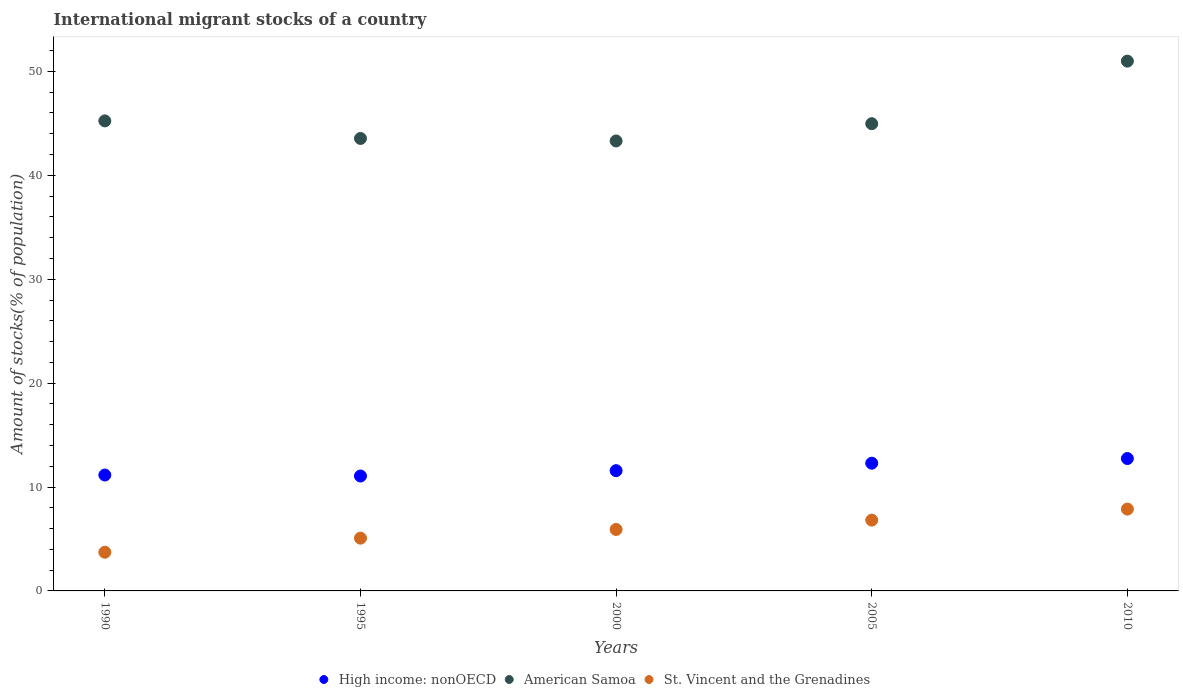Is the number of dotlines equal to the number of legend labels?
Ensure brevity in your answer.  Yes. What is the amount of stocks in in St. Vincent and the Grenadines in 1990?
Give a very brief answer. 3.72. Across all years, what is the maximum amount of stocks in in St. Vincent and the Grenadines?
Make the answer very short. 7.88. Across all years, what is the minimum amount of stocks in in American Samoa?
Provide a succinct answer. 43.31. In which year was the amount of stocks in in American Samoa minimum?
Make the answer very short. 2000. What is the total amount of stocks in in American Samoa in the graph?
Your answer should be compact. 228.06. What is the difference between the amount of stocks in in High income: nonOECD in 1995 and that in 2010?
Provide a succinct answer. -1.68. What is the difference between the amount of stocks in in American Samoa in 1995 and the amount of stocks in in St. Vincent and the Grenadines in 2010?
Offer a very short reply. 35.67. What is the average amount of stocks in in St. Vincent and the Grenadines per year?
Keep it short and to the point. 5.88. In the year 2010, what is the difference between the amount of stocks in in American Samoa and amount of stocks in in St. Vincent and the Grenadines?
Offer a very short reply. 43.11. What is the ratio of the amount of stocks in in St. Vincent and the Grenadines in 1990 to that in 2000?
Give a very brief answer. 0.63. Is the amount of stocks in in American Samoa in 1990 less than that in 2000?
Your answer should be compact. No. What is the difference between the highest and the second highest amount of stocks in in St. Vincent and the Grenadines?
Make the answer very short. 1.06. What is the difference between the highest and the lowest amount of stocks in in American Samoa?
Provide a short and direct response. 7.68. Is the sum of the amount of stocks in in American Samoa in 2005 and 2010 greater than the maximum amount of stocks in in High income: nonOECD across all years?
Your answer should be compact. Yes. Is it the case that in every year, the sum of the amount of stocks in in High income: nonOECD and amount of stocks in in St. Vincent and the Grenadines  is greater than the amount of stocks in in American Samoa?
Keep it short and to the point. No. Is the amount of stocks in in American Samoa strictly less than the amount of stocks in in High income: nonOECD over the years?
Keep it short and to the point. No. How many dotlines are there?
Keep it short and to the point. 3. How many years are there in the graph?
Give a very brief answer. 5. What is the difference between two consecutive major ticks on the Y-axis?
Offer a very short reply. 10. Are the values on the major ticks of Y-axis written in scientific E-notation?
Your response must be concise. No. Does the graph contain grids?
Your answer should be very brief. No. How are the legend labels stacked?
Provide a short and direct response. Horizontal. What is the title of the graph?
Your answer should be compact. International migrant stocks of a country. Does "Moldova" appear as one of the legend labels in the graph?
Ensure brevity in your answer.  No. What is the label or title of the X-axis?
Keep it short and to the point. Years. What is the label or title of the Y-axis?
Provide a short and direct response. Amount of stocks(% of population). What is the Amount of stocks(% of population) of High income: nonOECD in 1990?
Make the answer very short. 11.16. What is the Amount of stocks(% of population) in American Samoa in 1990?
Your response must be concise. 45.24. What is the Amount of stocks(% of population) in St. Vincent and the Grenadines in 1990?
Your response must be concise. 3.72. What is the Amount of stocks(% of population) of High income: nonOECD in 1995?
Provide a short and direct response. 11.06. What is the Amount of stocks(% of population) of American Samoa in 1995?
Offer a terse response. 43.55. What is the Amount of stocks(% of population) of St. Vincent and the Grenadines in 1995?
Give a very brief answer. 5.08. What is the Amount of stocks(% of population) of High income: nonOECD in 2000?
Make the answer very short. 11.58. What is the Amount of stocks(% of population) of American Samoa in 2000?
Provide a short and direct response. 43.31. What is the Amount of stocks(% of population) of St. Vincent and the Grenadines in 2000?
Give a very brief answer. 5.91. What is the Amount of stocks(% of population) in High income: nonOECD in 2005?
Offer a very short reply. 12.29. What is the Amount of stocks(% of population) of American Samoa in 2005?
Your answer should be compact. 44.97. What is the Amount of stocks(% of population) in St. Vincent and the Grenadines in 2005?
Your answer should be very brief. 6.82. What is the Amount of stocks(% of population) in High income: nonOECD in 2010?
Make the answer very short. 12.74. What is the Amount of stocks(% of population) in American Samoa in 2010?
Ensure brevity in your answer.  50.99. What is the Amount of stocks(% of population) in St. Vincent and the Grenadines in 2010?
Keep it short and to the point. 7.88. Across all years, what is the maximum Amount of stocks(% of population) of High income: nonOECD?
Provide a short and direct response. 12.74. Across all years, what is the maximum Amount of stocks(% of population) of American Samoa?
Your answer should be compact. 50.99. Across all years, what is the maximum Amount of stocks(% of population) of St. Vincent and the Grenadines?
Give a very brief answer. 7.88. Across all years, what is the minimum Amount of stocks(% of population) of High income: nonOECD?
Offer a terse response. 11.06. Across all years, what is the minimum Amount of stocks(% of population) in American Samoa?
Ensure brevity in your answer.  43.31. Across all years, what is the minimum Amount of stocks(% of population) in St. Vincent and the Grenadines?
Your answer should be compact. 3.72. What is the total Amount of stocks(% of population) in High income: nonOECD in the graph?
Make the answer very short. 58.83. What is the total Amount of stocks(% of population) of American Samoa in the graph?
Keep it short and to the point. 228.06. What is the total Amount of stocks(% of population) in St. Vincent and the Grenadines in the graph?
Give a very brief answer. 29.41. What is the difference between the Amount of stocks(% of population) in High income: nonOECD in 1990 and that in 1995?
Ensure brevity in your answer.  0.1. What is the difference between the Amount of stocks(% of population) of American Samoa in 1990 and that in 1995?
Offer a very short reply. 1.69. What is the difference between the Amount of stocks(% of population) in St. Vincent and the Grenadines in 1990 and that in 1995?
Keep it short and to the point. -1.36. What is the difference between the Amount of stocks(% of population) in High income: nonOECD in 1990 and that in 2000?
Your answer should be compact. -0.42. What is the difference between the Amount of stocks(% of population) of American Samoa in 1990 and that in 2000?
Ensure brevity in your answer.  1.93. What is the difference between the Amount of stocks(% of population) in St. Vincent and the Grenadines in 1990 and that in 2000?
Give a very brief answer. -2.19. What is the difference between the Amount of stocks(% of population) in High income: nonOECD in 1990 and that in 2005?
Provide a short and direct response. -1.14. What is the difference between the Amount of stocks(% of population) of American Samoa in 1990 and that in 2005?
Provide a succinct answer. 0.27. What is the difference between the Amount of stocks(% of population) of St. Vincent and the Grenadines in 1990 and that in 2005?
Keep it short and to the point. -3.09. What is the difference between the Amount of stocks(% of population) of High income: nonOECD in 1990 and that in 2010?
Your answer should be very brief. -1.59. What is the difference between the Amount of stocks(% of population) in American Samoa in 1990 and that in 2010?
Provide a succinct answer. -5.75. What is the difference between the Amount of stocks(% of population) in St. Vincent and the Grenadines in 1990 and that in 2010?
Your answer should be very brief. -4.15. What is the difference between the Amount of stocks(% of population) of High income: nonOECD in 1995 and that in 2000?
Ensure brevity in your answer.  -0.52. What is the difference between the Amount of stocks(% of population) of American Samoa in 1995 and that in 2000?
Your answer should be compact. 0.24. What is the difference between the Amount of stocks(% of population) in St. Vincent and the Grenadines in 1995 and that in 2000?
Keep it short and to the point. -0.83. What is the difference between the Amount of stocks(% of population) in High income: nonOECD in 1995 and that in 2005?
Provide a short and direct response. -1.23. What is the difference between the Amount of stocks(% of population) in American Samoa in 1995 and that in 2005?
Provide a succinct answer. -1.42. What is the difference between the Amount of stocks(% of population) of St. Vincent and the Grenadines in 1995 and that in 2005?
Your response must be concise. -1.74. What is the difference between the Amount of stocks(% of population) in High income: nonOECD in 1995 and that in 2010?
Provide a succinct answer. -1.68. What is the difference between the Amount of stocks(% of population) in American Samoa in 1995 and that in 2010?
Make the answer very short. -7.44. What is the difference between the Amount of stocks(% of population) in St. Vincent and the Grenadines in 1995 and that in 2010?
Ensure brevity in your answer.  -2.8. What is the difference between the Amount of stocks(% of population) of High income: nonOECD in 2000 and that in 2005?
Your response must be concise. -0.72. What is the difference between the Amount of stocks(% of population) of American Samoa in 2000 and that in 2005?
Offer a terse response. -1.66. What is the difference between the Amount of stocks(% of population) of St. Vincent and the Grenadines in 2000 and that in 2005?
Your response must be concise. -0.9. What is the difference between the Amount of stocks(% of population) of High income: nonOECD in 2000 and that in 2010?
Give a very brief answer. -1.17. What is the difference between the Amount of stocks(% of population) of American Samoa in 2000 and that in 2010?
Your answer should be very brief. -7.68. What is the difference between the Amount of stocks(% of population) in St. Vincent and the Grenadines in 2000 and that in 2010?
Keep it short and to the point. -1.96. What is the difference between the Amount of stocks(% of population) of High income: nonOECD in 2005 and that in 2010?
Your response must be concise. -0.45. What is the difference between the Amount of stocks(% of population) of American Samoa in 2005 and that in 2010?
Offer a very short reply. -6.02. What is the difference between the Amount of stocks(% of population) of St. Vincent and the Grenadines in 2005 and that in 2010?
Give a very brief answer. -1.06. What is the difference between the Amount of stocks(% of population) of High income: nonOECD in 1990 and the Amount of stocks(% of population) of American Samoa in 1995?
Offer a terse response. -32.39. What is the difference between the Amount of stocks(% of population) in High income: nonOECD in 1990 and the Amount of stocks(% of population) in St. Vincent and the Grenadines in 1995?
Provide a succinct answer. 6.08. What is the difference between the Amount of stocks(% of population) in American Samoa in 1990 and the Amount of stocks(% of population) in St. Vincent and the Grenadines in 1995?
Give a very brief answer. 40.16. What is the difference between the Amount of stocks(% of population) of High income: nonOECD in 1990 and the Amount of stocks(% of population) of American Samoa in 2000?
Offer a very short reply. -32.15. What is the difference between the Amount of stocks(% of population) of High income: nonOECD in 1990 and the Amount of stocks(% of population) of St. Vincent and the Grenadines in 2000?
Offer a terse response. 5.24. What is the difference between the Amount of stocks(% of population) of American Samoa in 1990 and the Amount of stocks(% of population) of St. Vincent and the Grenadines in 2000?
Your response must be concise. 39.33. What is the difference between the Amount of stocks(% of population) of High income: nonOECD in 1990 and the Amount of stocks(% of population) of American Samoa in 2005?
Offer a very short reply. -33.81. What is the difference between the Amount of stocks(% of population) in High income: nonOECD in 1990 and the Amount of stocks(% of population) in St. Vincent and the Grenadines in 2005?
Give a very brief answer. 4.34. What is the difference between the Amount of stocks(% of population) of American Samoa in 1990 and the Amount of stocks(% of population) of St. Vincent and the Grenadines in 2005?
Your answer should be compact. 38.42. What is the difference between the Amount of stocks(% of population) of High income: nonOECD in 1990 and the Amount of stocks(% of population) of American Samoa in 2010?
Keep it short and to the point. -39.84. What is the difference between the Amount of stocks(% of population) of High income: nonOECD in 1990 and the Amount of stocks(% of population) of St. Vincent and the Grenadines in 2010?
Offer a very short reply. 3.28. What is the difference between the Amount of stocks(% of population) of American Samoa in 1990 and the Amount of stocks(% of population) of St. Vincent and the Grenadines in 2010?
Offer a terse response. 37.36. What is the difference between the Amount of stocks(% of population) of High income: nonOECD in 1995 and the Amount of stocks(% of population) of American Samoa in 2000?
Your answer should be very brief. -32.25. What is the difference between the Amount of stocks(% of population) of High income: nonOECD in 1995 and the Amount of stocks(% of population) of St. Vincent and the Grenadines in 2000?
Offer a terse response. 5.15. What is the difference between the Amount of stocks(% of population) of American Samoa in 1995 and the Amount of stocks(% of population) of St. Vincent and the Grenadines in 2000?
Provide a succinct answer. 37.64. What is the difference between the Amount of stocks(% of population) of High income: nonOECD in 1995 and the Amount of stocks(% of population) of American Samoa in 2005?
Offer a very short reply. -33.91. What is the difference between the Amount of stocks(% of population) in High income: nonOECD in 1995 and the Amount of stocks(% of population) in St. Vincent and the Grenadines in 2005?
Offer a very short reply. 4.24. What is the difference between the Amount of stocks(% of population) of American Samoa in 1995 and the Amount of stocks(% of population) of St. Vincent and the Grenadines in 2005?
Ensure brevity in your answer.  36.73. What is the difference between the Amount of stocks(% of population) of High income: nonOECD in 1995 and the Amount of stocks(% of population) of American Samoa in 2010?
Your response must be concise. -39.93. What is the difference between the Amount of stocks(% of population) of High income: nonOECD in 1995 and the Amount of stocks(% of population) of St. Vincent and the Grenadines in 2010?
Make the answer very short. 3.18. What is the difference between the Amount of stocks(% of population) of American Samoa in 1995 and the Amount of stocks(% of population) of St. Vincent and the Grenadines in 2010?
Your answer should be compact. 35.67. What is the difference between the Amount of stocks(% of population) in High income: nonOECD in 2000 and the Amount of stocks(% of population) in American Samoa in 2005?
Make the answer very short. -33.39. What is the difference between the Amount of stocks(% of population) of High income: nonOECD in 2000 and the Amount of stocks(% of population) of St. Vincent and the Grenadines in 2005?
Offer a very short reply. 4.76. What is the difference between the Amount of stocks(% of population) of American Samoa in 2000 and the Amount of stocks(% of population) of St. Vincent and the Grenadines in 2005?
Provide a succinct answer. 36.49. What is the difference between the Amount of stocks(% of population) in High income: nonOECD in 2000 and the Amount of stocks(% of population) in American Samoa in 2010?
Provide a succinct answer. -39.42. What is the difference between the Amount of stocks(% of population) in High income: nonOECD in 2000 and the Amount of stocks(% of population) in St. Vincent and the Grenadines in 2010?
Ensure brevity in your answer.  3.7. What is the difference between the Amount of stocks(% of population) in American Samoa in 2000 and the Amount of stocks(% of population) in St. Vincent and the Grenadines in 2010?
Ensure brevity in your answer.  35.43. What is the difference between the Amount of stocks(% of population) in High income: nonOECD in 2005 and the Amount of stocks(% of population) in American Samoa in 2010?
Make the answer very short. -38.7. What is the difference between the Amount of stocks(% of population) in High income: nonOECD in 2005 and the Amount of stocks(% of population) in St. Vincent and the Grenadines in 2010?
Provide a short and direct response. 4.42. What is the difference between the Amount of stocks(% of population) of American Samoa in 2005 and the Amount of stocks(% of population) of St. Vincent and the Grenadines in 2010?
Give a very brief answer. 37.09. What is the average Amount of stocks(% of population) of High income: nonOECD per year?
Ensure brevity in your answer.  11.77. What is the average Amount of stocks(% of population) of American Samoa per year?
Provide a succinct answer. 45.61. What is the average Amount of stocks(% of population) of St. Vincent and the Grenadines per year?
Provide a succinct answer. 5.88. In the year 1990, what is the difference between the Amount of stocks(% of population) of High income: nonOECD and Amount of stocks(% of population) of American Samoa?
Ensure brevity in your answer.  -34.08. In the year 1990, what is the difference between the Amount of stocks(% of population) of High income: nonOECD and Amount of stocks(% of population) of St. Vincent and the Grenadines?
Give a very brief answer. 7.43. In the year 1990, what is the difference between the Amount of stocks(% of population) of American Samoa and Amount of stocks(% of population) of St. Vincent and the Grenadines?
Your response must be concise. 41.52. In the year 1995, what is the difference between the Amount of stocks(% of population) of High income: nonOECD and Amount of stocks(% of population) of American Samoa?
Provide a short and direct response. -32.49. In the year 1995, what is the difference between the Amount of stocks(% of population) in High income: nonOECD and Amount of stocks(% of population) in St. Vincent and the Grenadines?
Offer a very short reply. 5.98. In the year 1995, what is the difference between the Amount of stocks(% of population) of American Samoa and Amount of stocks(% of population) of St. Vincent and the Grenadines?
Make the answer very short. 38.47. In the year 2000, what is the difference between the Amount of stocks(% of population) in High income: nonOECD and Amount of stocks(% of population) in American Samoa?
Ensure brevity in your answer.  -31.73. In the year 2000, what is the difference between the Amount of stocks(% of population) in High income: nonOECD and Amount of stocks(% of population) in St. Vincent and the Grenadines?
Ensure brevity in your answer.  5.66. In the year 2000, what is the difference between the Amount of stocks(% of population) of American Samoa and Amount of stocks(% of population) of St. Vincent and the Grenadines?
Make the answer very short. 37.4. In the year 2005, what is the difference between the Amount of stocks(% of population) of High income: nonOECD and Amount of stocks(% of population) of American Samoa?
Provide a short and direct response. -32.68. In the year 2005, what is the difference between the Amount of stocks(% of population) of High income: nonOECD and Amount of stocks(% of population) of St. Vincent and the Grenadines?
Your answer should be very brief. 5.48. In the year 2005, what is the difference between the Amount of stocks(% of population) of American Samoa and Amount of stocks(% of population) of St. Vincent and the Grenadines?
Your answer should be very brief. 38.15. In the year 2010, what is the difference between the Amount of stocks(% of population) in High income: nonOECD and Amount of stocks(% of population) in American Samoa?
Offer a terse response. -38.25. In the year 2010, what is the difference between the Amount of stocks(% of population) of High income: nonOECD and Amount of stocks(% of population) of St. Vincent and the Grenadines?
Your response must be concise. 4.87. In the year 2010, what is the difference between the Amount of stocks(% of population) of American Samoa and Amount of stocks(% of population) of St. Vincent and the Grenadines?
Offer a very short reply. 43.12. What is the ratio of the Amount of stocks(% of population) in High income: nonOECD in 1990 to that in 1995?
Ensure brevity in your answer.  1.01. What is the ratio of the Amount of stocks(% of population) of American Samoa in 1990 to that in 1995?
Your answer should be very brief. 1.04. What is the ratio of the Amount of stocks(% of population) of St. Vincent and the Grenadines in 1990 to that in 1995?
Make the answer very short. 0.73. What is the ratio of the Amount of stocks(% of population) in High income: nonOECD in 1990 to that in 2000?
Make the answer very short. 0.96. What is the ratio of the Amount of stocks(% of population) in American Samoa in 1990 to that in 2000?
Keep it short and to the point. 1.04. What is the ratio of the Amount of stocks(% of population) of St. Vincent and the Grenadines in 1990 to that in 2000?
Make the answer very short. 0.63. What is the ratio of the Amount of stocks(% of population) of High income: nonOECD in 1990 to that in 2005?
Offer a terse response. 0.91. What is the ratio of the Amount of stocks(% of population) of St. Vincent and the Grenadines in 1990 to that in 2005?
Keep it short and to the point. 0.55. What is the ratio of the Amount of stocks(% of population) of High income: nonOECD in 1990 to that in 2010?
Ensure brevity in your answer.  0.88. What is the ratio of the Amount of stocks(% of population) of American Samoa in 1990 to that in 2010?
Make the answer very short. 0.89. What is the ratio of the Amount of stocks(% of population) in St. Vincent and the Grenadines in 1990 to that in 2010?
Your answer should be compact. 0.47. What is the ratio of the Amount of stocks(% of population) in High income: nonOECD in 1995 to that in 2000?
Your answer should be very brief. 0.96. What is the ratio of the Amount of stocks(% of population) in St. Vincent and the Grenadines in 1995 to that in 2000?
Offer a very short reply. 0.86. What is the ratio of the Amount of stocks(% of population) of High income: nonOECD in 1995 to that in 2005?
Make the answer very short. 0.9. What is the ratio of the Amount of stocks(% of population) of American Samoa in 1995 to that in 2005?
Your answer should be compact. 0.97. What is the ratio of the Amount of stocks(% of population) in St. Vincent and the Grenadines in 1995 to that in 2005?
Give a very brief answer. 0.75. What is the ratio of the Amount of stocks(% of population) in High income: nonOECD in 1995 to that in 2010?
Your answer should be very brief. 0.87. What is the ratio of the Amount of stocks(% of population) in American Samoa in 1995 to that in 2010?
Keep it short and to the point. 0.85. What is the ratio of the Amount of stocks(% of population) in St. Vincent and the Grenadines in 1995 to that in 2010?
Your response must be concise. 0.64. What is the ratio of the Amount of stocks(% of population) of High income: nonOECD in 2000 to that in 2005?
Offer a very short reply. 0.94. What is the ratio of the Amount of stocks(% of population) in American Samoa in 2000 to that in 2005?
Provide a succinct answer. 0.96. What is the ratio of the Amount of stocks(% of population) of St. Vincent and the Grenadines in 2000 to that in 2005?
Make the answer very short. 0.87. What is the ratio of the Amount of stocks(% of population) of High income: nonOECD in 2000 to that in 2010?
Your response must be concise. 0.91. What is the ratio of the Amount of stocks(% of population) in American Samoa in 2000 to that in 2010?
Give a very brief answer. 0.85. What is the ratio of the Amount of stocks(% of population) in St. Vincent and the Grenadines in 2000 to that in 2010?
Your response must be concise. 0.75. What is the ratio of the Amount of stocks(% of population) of High income: nonOECD in 2005 to that in 2010?
Your answer should be compact. 0.96. What is the ratio of the Amount of stocks(% of population) of American Samoa in 2005 to that in 2010?
Provide a short and direct response. 0.88. What is the ratio of the Amount of stocks(% of population) of St. Vincent and the Grenadines in 2005 to that in 2010?
Provide a succinct answer. 0.87. What is the difference between the highest and the second highest Amount of stocks(% of population) of High income: nonOECD?
Give a very brief answer. 0.45. What is the difference between the highest and the second highest Amount of stocks(% of population) in American Samoa?
Give a very brief answer. 5.75. What is the difference between the highest and the second highest Amount of stocks(% of population) of St. Vincent and the Grenadines?
Keep it short and to the point. 1.06. What is the difference between the highest and the lowest Amount of stocks(% of population) in High income: nonOECD?
Your answer should be compact. 1.68. What is the difference between the highest and the lowest Amount of stocks(% of population) of American Samoa?
Ensure brevity in your answer.  7.68. What is the difference between the highest and the lowest Amount of stocks(% of population) of St. Vincent and the Grenadines?
Provide a short and direct response. 4.15. 